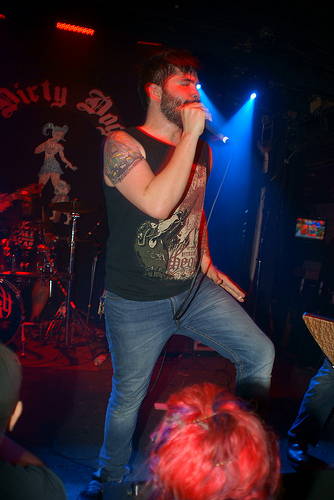<image>
Can you confirm if the mic stand is in front of the man? No. The mic stand is not in front of the man. The spatial positioning shows a different relationship between these objects. 